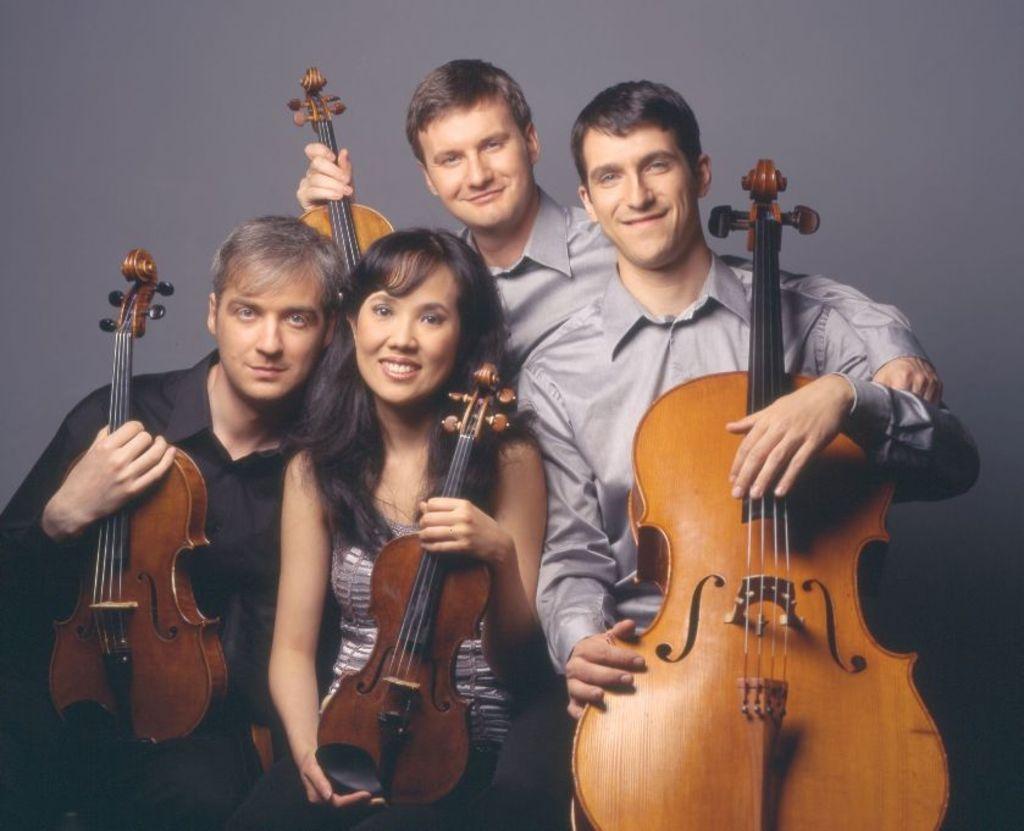How would you summarize this image in a sentence or two? In this picture, we see five people holding guitar in their hands. Among them, there are men and a woman and all of them are laughing. Behind them, we see a wall which is grey in color. 